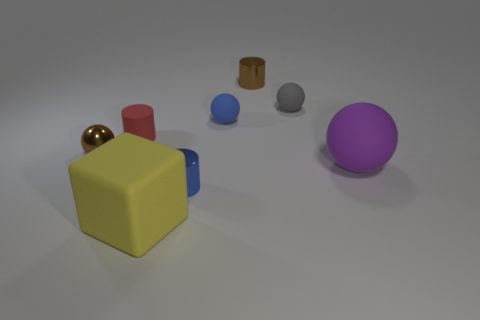Is the material of the yellow thing the same as the brown object to the left of the yellow rubber block?
Your response must be concise. No. How many other objects are the same shape as the tiny blue shiny object?
Provide a short and direct response. 2. How many things are either metallic spheres in front of the small blue ball or brown metal things on the left side of the blue cylinder?
Provide a succinct answer. 1. How many other objects are there of the same color as the tiny metal sphere?
Give a very brief answer. 1. Is the number of cylinders that are behind the tiny gray matte object less than the number of brown cylinders in front of the brown metallic cylinder?
Give a very brief answer. No. What number of large blue rubber cylinders are there?
Your answer should be compact. 0. Are there any other things that have the same material as the red cylinder?
Offer a terse response. Yes. There is a gray thing that is the same shape as the big purple object; what material is it?
Keep it short and to the point. Rubber. Is the number of yellow blocks that are to the right of the large matte block less than the number of tiny blue rubber spheres?
Your answer should be compact. Yes. There is a tiny brown object right of the brown sphere; is its shape the same as the yellow object?
Your answer should be compact. No. 